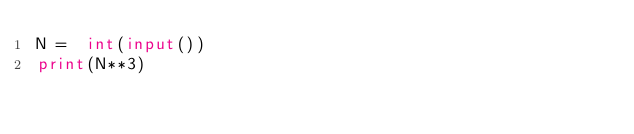<code> <loc_0><loc_0><loc_500><loc_500><_Python_>N =  int(input())
print(N**3)</code> 